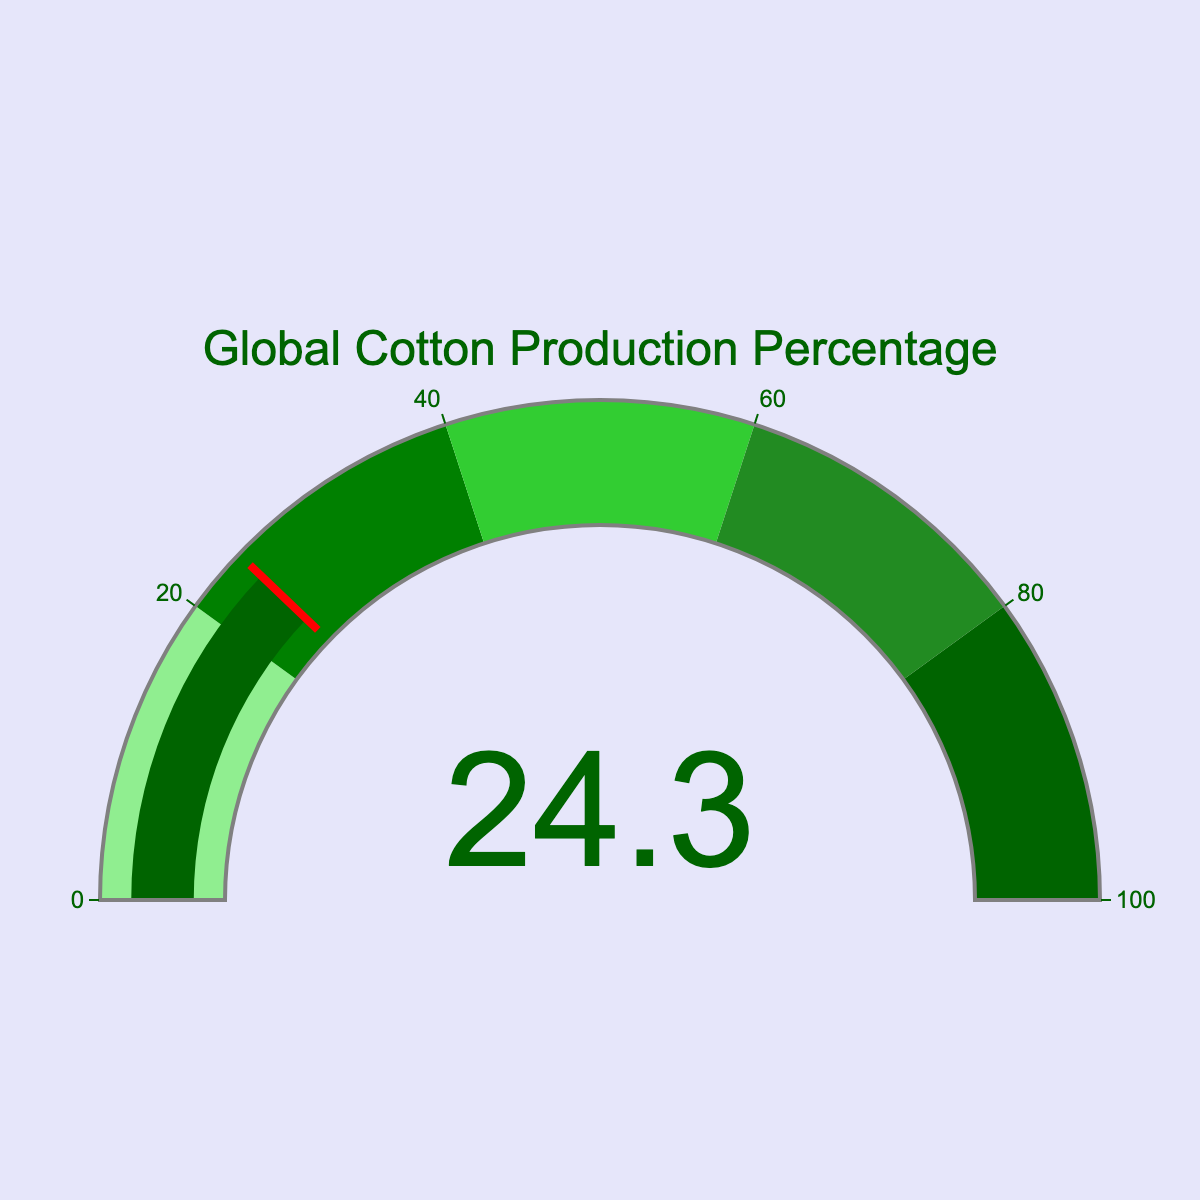What is the percentage of global cotton production according to the gauge chart? The gauge meter directly shows the percentage number which indicates the global cotton production. Looking at the meter, it clearly reads 24.3%.
Answer: 24.3% What is the title of the gauge chart? The title is displayed prominently above the gauge in a larger font. The text reads “Global Cotton Production Percentage.”
Answer: Global Cotton Production Percentage What color is used for the gauge needle and bar? Observing the gauge, we can see that the needle and the bar are colored in dark green.
Answer: Dark green What range does the dark green section of the gauge represent? The gauge is divided into different color-coded sections. The dark green section ranges from 80 to 100.
Answer: 80 to 100 Which color represents the range where the percentage of global cotton production falls? The cotton production percentage is 24.3%, which falls in the range with the green color on the gauge.
Answer: Green Compare the current global cotton production percentage with the gauge's midpoint (50%). Is it higher or lower? Comparing the global cotton production percentage (24.3%) with the midpoint (50%) of the gauge, 24.3% is lower than 50%.
Answer: Lower What does the red line on the gauge represent, and where is it positioned? The red line on the gauge indicates the current measure's specific value, positioned exactly at 24.3%.
Answer: 24.3% If the cotton percentage increases to 35% next year, in which color range would it fall? The current color ranges indicate that a percentage of 35% would fall in the green section of the gauge.
Answer: Green How does the cotton production percentage compare to the first color segment (0-20%)? The global cotton production percentage (24.3%) is greater than the values in the first color segment, which ranges from 0 to 20%.
Answer: Greater What is the maximum value on the gauge's scale? The gauge scale represents values up to 100.
Answer: 100 